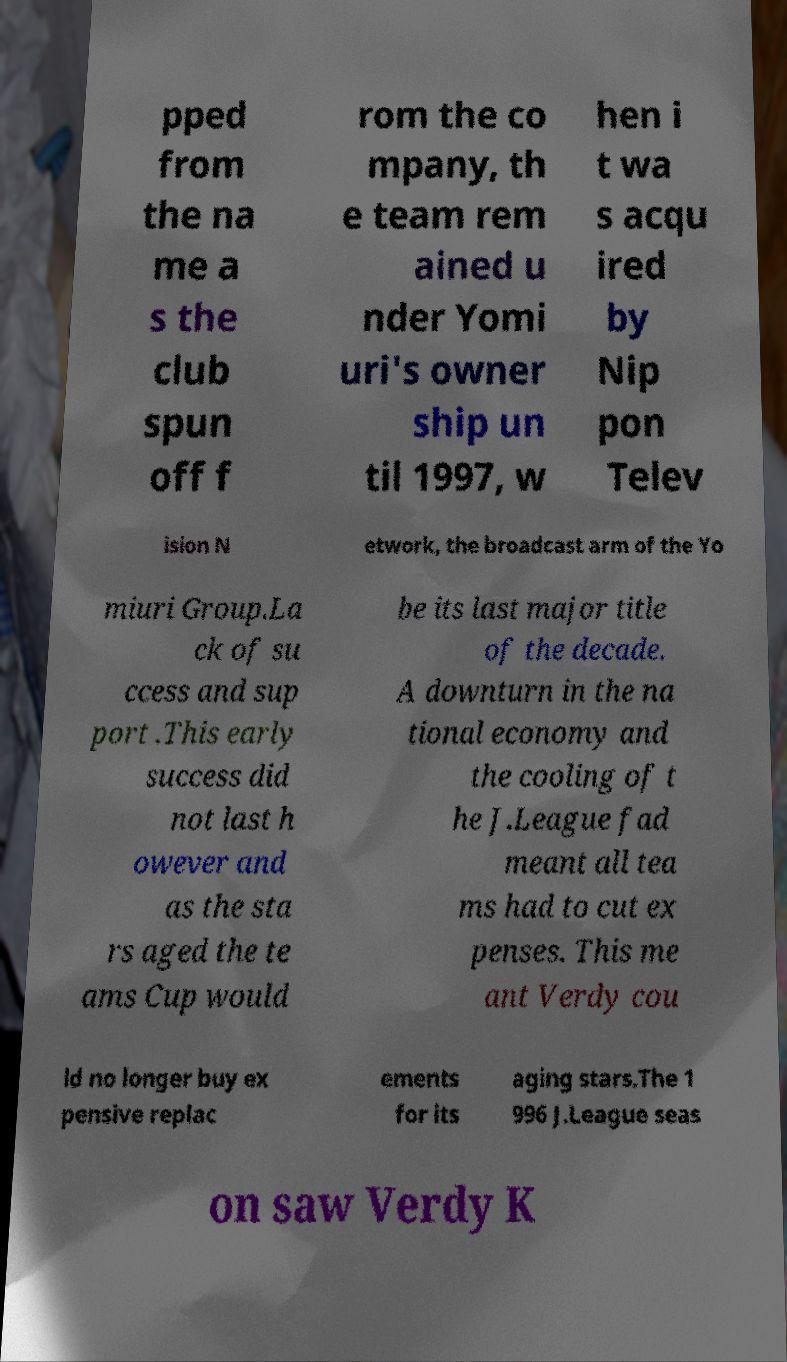Could you extract and type out the text from this image? pped from the na me a s the club spun off f rom the co mpany, th e team rem ained u nder Yomi uri's owner ship un til 1997, w hen i t wa s acqu ired by Nip pon Telev ision N etwork, the broadcast arm of the Yo miuri Group.La ck of su ccess and sup port .This early success did not last h owever and as the sta rs aged the te ams Cup would be its last major title of the decade. A downturn in the na tional economy and the cooling of t he J.League fad meant all tea ms had to cut ex penses. This me ant Verdy cou ld no longer buy ex pensive replac ements for its aging stars.The 1 996 J.League seas on saw Verdy K 